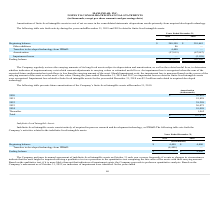According to Maxlinear's financial document, When does the company perform its annual assessment? According to the financial document, October 31. The relevant text states: "sessment of indefinite-lived intangible assets on October 31 each year or more frequently if events or changes in circumstances sessment of indefinite-lived intangible assets on October 31 each year o..." Also, What was the impairment loss recognized by the company in 2017? Based on the financial document, the answer is $2.0 million. Also, What were the Transfers to developed technology from IPR&D in 2019 and 2018 respectively? The document shows two values: (4,400) and 0 (in thousands). From the document: "Transfers to developed technology from IPR&D (4,400) — Transfers to developed technology from IPR&D (4,400) —..." Also, can you calculate: What was the change in the Transfers to developed technology from IPR&D from 2018 to 2019? Based on the calculation: -4,400 - 0, the result is -4400 (in thousands). This is based on the information: "Transfers to developed technology from IPR&D 4,400 — Transfers to developed technology from IPR&D 4,400 —..." The key data points involved are: 4,400. Also, can you calculate: What is the average ending balance for 2018 and 2019? To answer this question, I need to perform calculations using the financial data. The calculation is: (0 + 4,400) / 2, which equals 2200 (in thousands). This is based on the information: "Transfers to developed technology from IPR&D 4,400 — Transfers to developed technology from IPR&D 4,400 —..." The key data points involved are: 4,400. Additionally, In which year was Transfers to developed technology from IPR&D negative? According to the financial document, 2019. The relevant text states: "orth activity during the years ended December 31, 2019 and 2018 related to finite-lived intangible assets:..." 